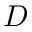Convert formula to latex. <formula><loc_0><loc_0><loc_500><loc_500>D</formula> 